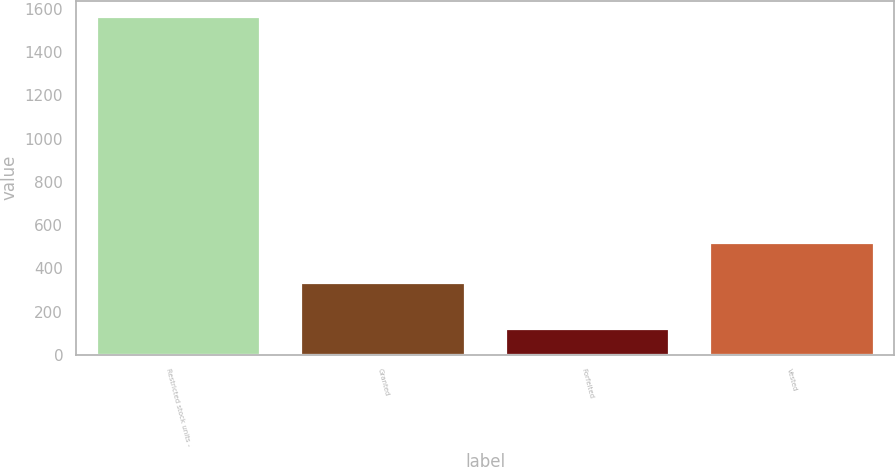<chart> <loc_0><loc_0><loc_500><loc_500><bar_chart><fcel>Restricted stock units -<fcel>Granted<fcel>Forfeited<fcel>Vested<nl><fcel>1560<fcel>334<fcel>117<fcel>519<nl></chart> 